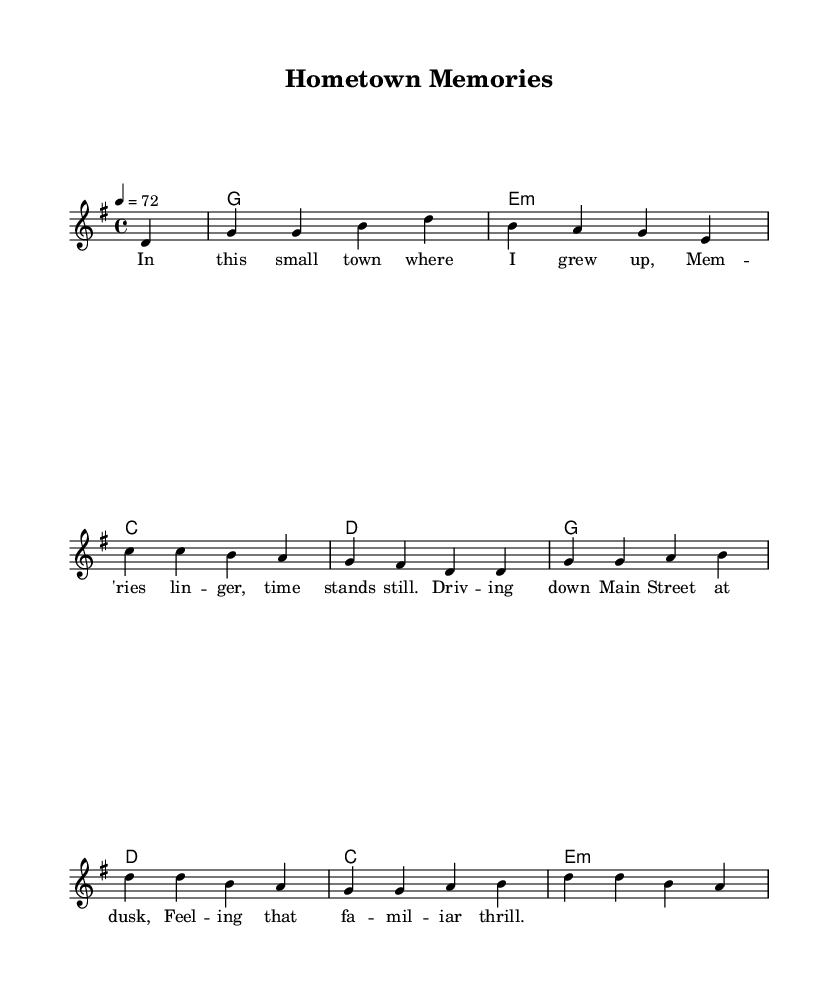What is the key signature of this music? The key signature indicated in the score is G major, which has one sharp (F#). This is determined by observing the key signature marker at the beginning of the staff.
Answer: G major What is the time signature of this music? The time signature shown in the score is 4/4, which means there are four beats in a measure and the quarter note gets one beat. This can be seen at the beginning of the piece where the time signature is displayed.
Answer: 4/4 What is the tempo marking for this music? The tempo marking in the score indicates that the piece should be played at a speed of 72 beats per minute. This is noted alongside the tempo indication near the top of the system.
Answer: 72 How many measures are there in the melody? Counting each measure from the start until the end, there are a total of 8 measures in the melody section. Each line represents a measure, and all are counted sequentially.
Answer: 8 What is the overall mood of the lyrics? The lyrics convey a nostalgic mood, reflecting on memories of growing up in a small town. This feeling comes from the word choices and imagery used throughout the lyrics.
Answer: Nostalgic Which chord follows the G chord in the harmony part? The chord that follows the G chord in the harmony part is E minor, as seen by analyzing the chord progression listed in the chord mode under the respective measures.
Answer: E minor What musical genre does this piece represent? The piece incorporates elements typical of country rock, evident from the lyrical themes of small-town life combined with the musical structure and instrumentation usually associated with both country and rock genres.
Answer: Country rock 